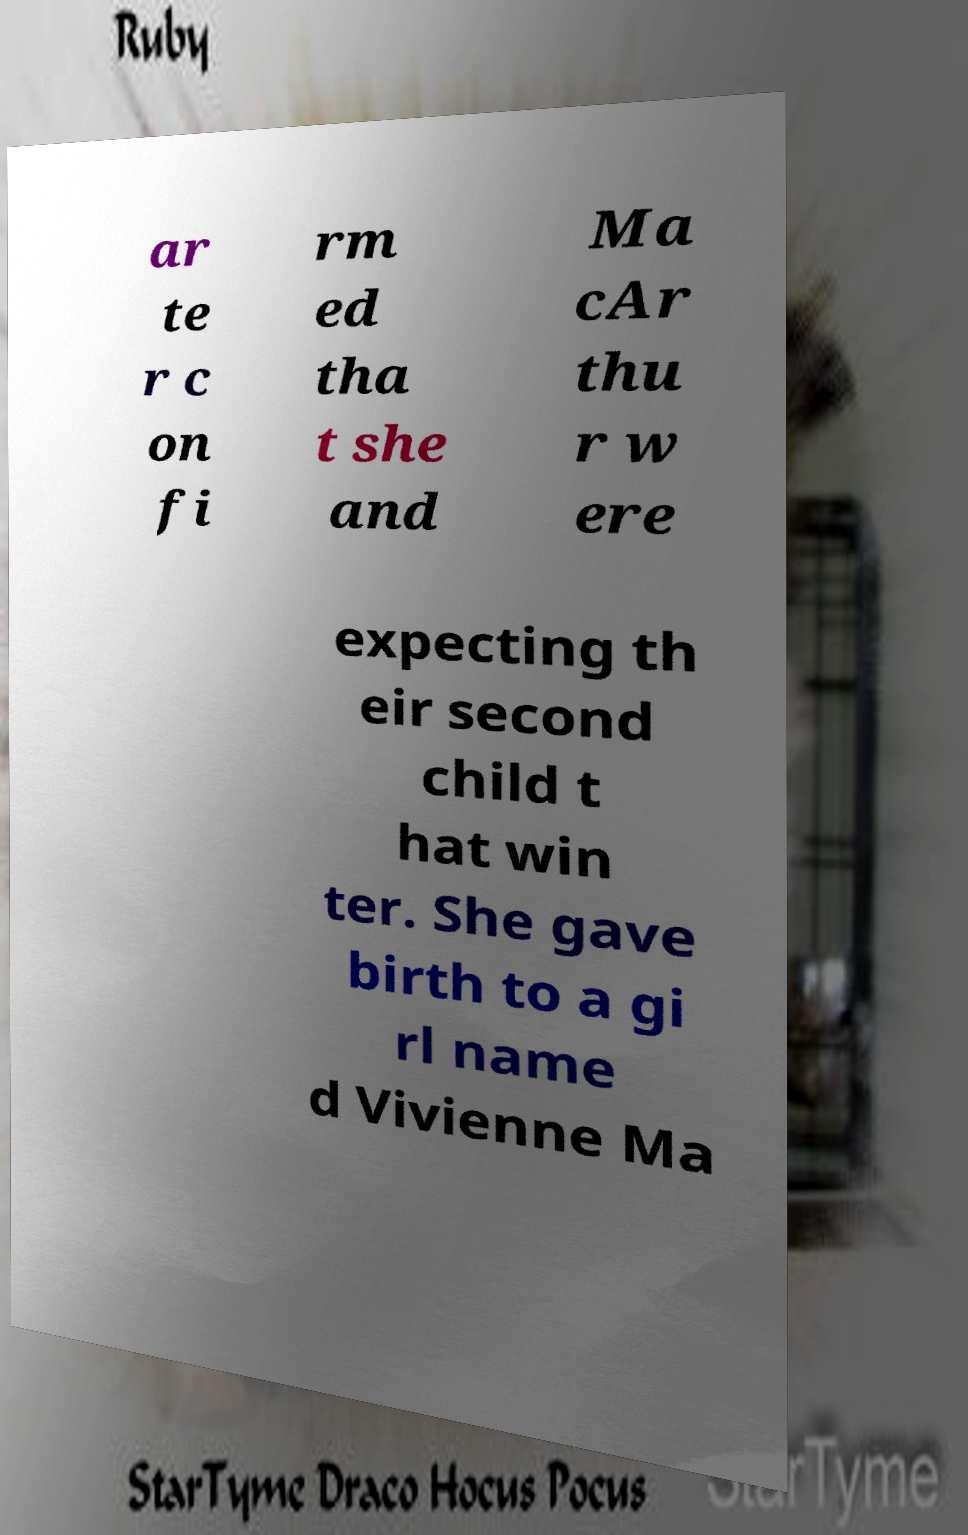Please read and relay the text visible in this image. What does it say? ar te r c on fi rm ed tha t she and Ma cAr thu r w ere expecting th eir second child t hat win ter. She gave birth to a gi rl name d Vivienne Ma 